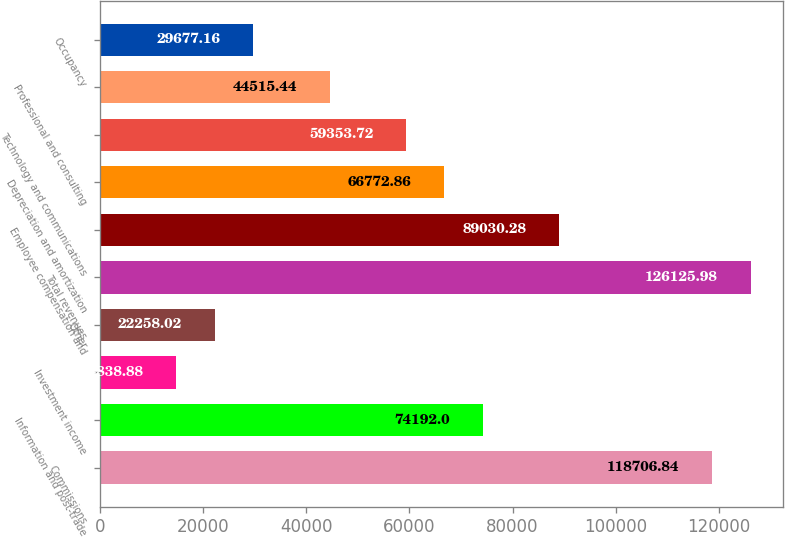<chart> <loc_0><loc_0><loc_500><loc_500><bar_chart><fcel>Commissions<fcel>Information and post-trade<fcel>Investment income<fcel>Other<fcel>Total revenues<fcel>Employee compensation and<fcel>Depreciation and amortization<fcel>Technology and communications<fcel>Professional and consulting<fcel>Occupancy<nl><fcel>118707<fcel>74192<fcel>14838.9<fcel>22258<fcel>126126<fcel>89030.3<fcel>66772.9<fcel>59353.7<fcel>44515.4<fcel>29677.2<nl></chart> 